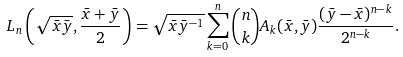<formula> <loc_0><loc_0><loc_500><loc_500>L _ { n } \left ( \sqrt { \bar { x } \bar { y } } , \frac { \bar { x } + \bar { y } } { 2 } \right ) = \sqrt { \bar { x } \bar { y } ^ { - 1 } } \sum _ { k = 0 } ^ { n } { n \choose k } A _ { k } ( \bar { x } , \bar { y } ) \frac { ( \bar { y } - \bar { x } ) ^ { n - k } } { 2 ^ { n - k } } .</formula> 